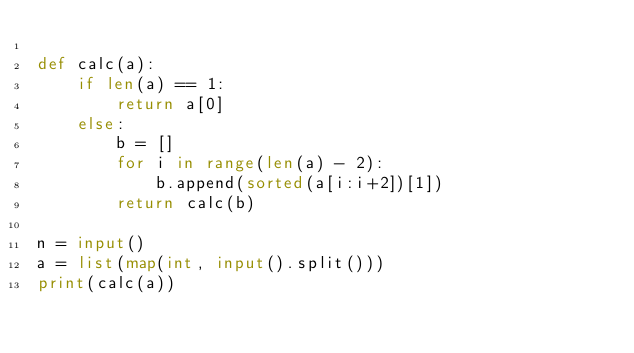<code> <loc_0><loc_0><loc_500><loc_500><_Python_>
def calc(a):
    if len(a) == 1:
        return a[0]
    else:
        b = []
        for i in range(len(a) - 2):
            b.append(sorted(a[i:i+2])[1])
        return calc(b)

n = input()
a = list(map(int, input().split()))
print(calc(a))</code> 